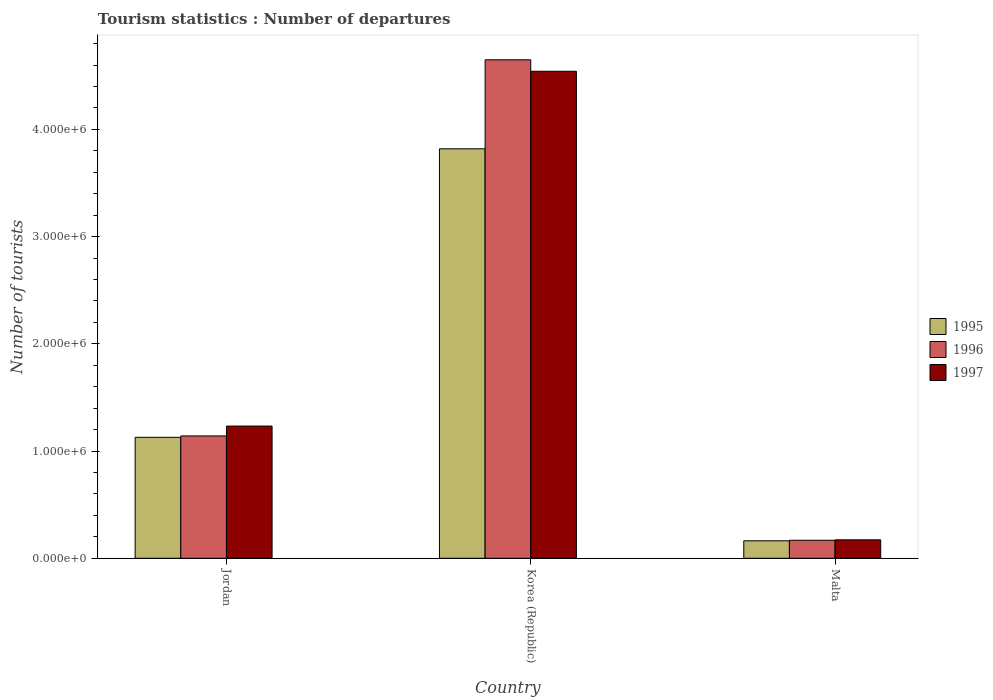How many groups of bars are there?
Make the answer very short. 3. Are the number of bars per tick equal to the number of legend labels?
Offer a terse response. Yes. What is the label of the 2nd group of bars from the left?
Make the answer very short. Korea (Republic). What is the number of tourist departures in 1996 in Malta?
Ensure brevity in your answer.  1.68e+05. Across all countries, what is the maximum number of tourist departures in 1995?
Provide a short and direct response. 3.82e+06. Across all countries, what is the minimum number of tourist departures in 1995?
Your answer should be very brief. 1.63e+05. In which country was the number of tourist departures in 1995 minimum?
Ensure brevity in your answer.  Malta. What is the total number of tourist departures in 1995 in the graph?
Ensure brevity in your answer.  5.11e+06. What is the difference between the number of tourist departures in 1997 in Jordan and that in Malta?
Keep it short and to the point. 1.06e+06. What is the difference between the number of tourist departures in 1997 in Malta and the number of tourist departures in 1995 in Korea (Republic)?
Provide a short and direct response. -3.65e+06. What is the average number of tourist departures in 1996 per country?
Provide a succinct answer. 1.99e+06. What is the difference between the number of tourist departures of/in 1996 and number of tourist departures of/in 1997 in Jordan?
Make the answer very short. -9.20e+04. In how many countries, is the number of tourist departures in 1996 greater than 1600000?
Your answer should be compact. 1. What is the ratio of the number of tourist departures in 1995 in Jordan to that in Korea (Republic)?
Your answer should be compact. 0.3. What is the difference between the highest and the second highest number of tourist departures in 1996?
Your response must be concise. 3.51e+06. What is the difference between the highest and the lowest number of tourist departures in 1995?
Provide a succinct answer. 3.66e+06. In how many countries, is the number of tourist departures in 1996 greater than the average number of tourist departures in 1996 taken over all countries?
Your answer should be compact. 1. What does the 1st bar from the left in Malta represents?
Offer a very short reply. 1995. Is it the case that in every country, the sum of the number of tourist departures in 1996 and number of tourist departures in 1997 is greater than the number of tourist departures in 1995?
Keep it short and to the point. Yes. Are the values on the major ticks of Y-axis written in scientific E-notation?
Offer a very short reply. Yes. Does the graph contain grids?
Provide a short and direct response. No. Where does the legend appear in the graph?
Offer a terse response. Center right. How many legend labels are there?
Your response must be concise. 3. How are the legend labels stacked?
Keep it short and to the point. Vertical. What is the title of the graph?
Your answer should be compact. Tourism statistics : Number of departures. Does "2010" appear as one of the legend labels in the graph?
Make the answer very short. No. What is the label or title of the X-axis?
Provide a short and direct response. Country. What is the label or title of the Y-axis?
Your response must be concise. Number of tourists. What is the Number of tourists of 1995 in Jordan?
Make the answer very short. 1.13e+06. What is the Number of tourists of 1996 in Jordan?
Make the answer very short. 1.14e+06. What is the Number of tourists in 1997 in Jordan?
Make the answer very short. 1.23e+06. What is the Number of tourists of 1995 in Korea (Republic)?
Keep it short and to the point. 3.82e+06. What is the Number of tourists of 1996 in Korea (Republic)?
Offer a very short reply. 4.65e+06. What is the Number of tourists in 1997 in Korea (Republic)?
Provide a short and direct response. 4.54e+06. What is the Number of tourists of 1995 in Malta?
Offer a terse response. 1.63e+05. What is the Number of tourists of 1996 in Malta?
Your answer should be compact. 1.68e+05. What is the Number of tourists of 1997 in Malta?
Ensure brevity in your answer.  1.72e+05. Across all countries, what is the maximum Number of tourists of 1995?
Your answer should be compact. 3.82e+06. Across all countries, what is the maximum Number of tourists of 1996?
Your response must be concise. 4.65e+06. Across all countries, what is the maximum Number of tourists of 1997?
Offer a very short reply. 4.54e+06. Across all countries, what is the minimum Number of tourists of 1995?
Your answer should be compact. 1.63e+05. Across all countries, what is the minimum Number of tourists in 1996?
Ensure brevity in your answer.  1.68e+05. Across all countries, what is the minimum Number of tourists in 1997?
Make the answer very short. 1.72e+05. What is the total Number of tourists of 1995 in the graph?
Your response must be concise. 5.11e+06. What is the total Number of tourists of 1996 in the graph?
Give a very brief answer. 5.96e+06. What is the total Number of tourists of 1997 in the graph?
Provide a short and direct response. 5.95e+06. What is the difference between the Number of tourists of 1995 in Jordan and that in Korea (Republic)?
Ensure brevity in your answer.  -2.69e+06. What is the difference between the Number of tourists in 1996 in Jordan and that in Korea (Republic)?
Make the answer very short. -3.51e+06. What is the difference between the Number of tourists of 1997 in Jordan and that in Korea (Republic)?
Provide a short and direct response. -3.31e+06. What is the difference between the Number of tourists in 1995 in Jordan and that in Malta?
Your answer should be compact. 9.65e+05. What is the difference between the Number of tourists of 1996 in Jordan and that in Malta?
Keep it short and to the point. 9.73e+05. What is the difference between the Number of tourists of 1997 in Jordan and that in Malta?
Offer a very short reply. 1.06e+06. What is the difference between the Number of tourists in 1995 in Korea (Republic) and that in Malta?
Provide a succinct answer. 3.66e+06. What is the difference between the Number of tourists of 1996 in Korea (Republic) and that in Malta?
Provide a short and direct response. 4.48e+06. What is the difference between the Number of tourists of 1997 in Korea (Republic) and that in Malta?
Offer a very short reply. 4.37e+06. What is the difference between the Number of tourists in 1995 in Jordan and the Number of tourists in 1996 in Korea (Republic)?
Provide a short and direct response. -3.52e+06. What is the difference between the Number of tourists of 1995 in Jordan and the Number of tourists of 1997 in Korea (Republic)?
Provide a succinct answer. -3.41e+06. What is the difference between the Number of tourists in 1996 in Jordan and the Number of tourists in 1997 in Korea (Republic)?
Provide a short and direct response. -3.40e+06. What is the difference between the Number of tourists in 1995 in Jordan and the Number of tourists in 1996 in Malta?
Keep it short and to the point. 9.60e+05. What is the difference between the Number of tourists in 1995 in Jordan and the Number of tourists in 1997 in Malta?
Provide a short and direct response. 9.56e+05. What is the difference between the Number of tourists of 1996 in Jordan and the Number of tourists of 1997 in Malta?
Offer a terse response. 9.69e+05. What is the difference between the Number of tourists of 1995 in Korea (Republic) and the Number of tourists of 1996 in Malta?
Ensure brevity in your answer.  3.65e+06. What is the difference between the Number of tourists of 1995 in Korea (Republic) and the Number of tourists of 1997 in Malta?
Make the answer very short. 3.65e+06. What is the difference between the Number of tourists of 1996 in Korea (Republic) and the Number of tourists of 1997 in Malta?
Your answer should be very brief. 4.48e+06. What is the average Number of tourists in 1995 per country?
Offer a terse response. 1.70e+06. What is the average Number of tourists of 1996 per country?
Provide a short and direct response. 1.99e+06. What is the average Number of tourists in 1997 per country?
Your answer should be compact. 1.98e+06. What is the difference between the Number of tourists in 1995 and Number of tourists in 1996 in Jordan?
Keep it short and to the point. -1.30e+04. What is the difference between the Number of tourists of 1995 and Number of tourists of 1997 in Jordan?
Ensure brevity in your answer.  -1.05e+05. What is the difference between the Number of tourists of 1996 and Number of tourists of 1997 in Jordan?
Your answer should be compact. -9.20e+04. What is the difference between the Number of tourists of 1995 and Number of tourists of 1996 in Korea (Republic)?
Keep it short and to the point. -8.30e+05. What is the difference between the Number of tourists in 1995 and Number of tourists in 1997 in Korea (Republic)?
Ensure brevity in your answer.  -7.23e+05. What is the difference between the Number of tourists of 1996 and Number of tourists of 1997 in Korea (Republic)?
Your response must be concise. 1.07e+05. What is the difference between the Number of tourists of 1995 and Number of tourists of 1996 in Malta?
Ensure brevity in your answer.  -5000. What is the difference between the Number of tourists of 1995 and Number of tourists of 1997 in Malta?
Provide a succinct answer. -9000. What is the difference between the Number of tourists in 1996 and Number of tourists in 1997 in Malta?
Offer a very short reply. -4000. What is the ratio of the Number of tourists in 1995 in Jordan to that in Korea (Republic)?
Keep it short and to the point. 0.3. What is the ratio of the Number of tourists in 1996 in Jordan to that in Korea (Republic)?
Keep it short and to the point. 0.25. What is the ratio of the Number of tourists of 1997 in Jordan to that in Korea (Republic)?
Offer a terse response. 0.27. What is the ratio of the Number of tourists in 1995 in Jordan to that in Malta?
Your response must be concise. 6.92. What is the ratio of the Number of tourists in 1996 in Jordan to that in Malta?
Give a very brief answer. 6.79. What is the ratio of the Number of tourists of 1997 in Jordan to that in Malta?
Your answer should be very brief. 7.17. What is the ratio of the Number of tourists of 1995 in Korea (Republic) to that in Malta?
Provide a short and direct response. 23.43. What is the ratio of the Number of tourists of 1996 in Korea (Republic) to that in Malta?
Provide a succinct answer. 27.67. What is the ratio of the Number of tourists in 1997 in Korea (Republic) to that in Malta?
Offer a terse response. 26.41. What is the difference between the highest and the second highest Number of tourists in 1995?
Your response must be concise. 2.69e+06. What is the difference between the highest and the second highest Number of tourists of 1996?
Your answer should be very brief. 3.51e+06. What is the difference between the highest and the second highest Number of tourists in 1997?
Make the answer very short. 3.31e+06. What is the difference between the highest and the lowest Number of tourists in 1995?
Offer a very short reply. 3.66e+06. What is the difference between the highest and the lowest Number of tourists in 1996?
Give a very brief answer. 4.48e+06. What is the difference between the highest and the lowest Number of tourists of 1997?
Make the answer very short. 4.37e+06. 